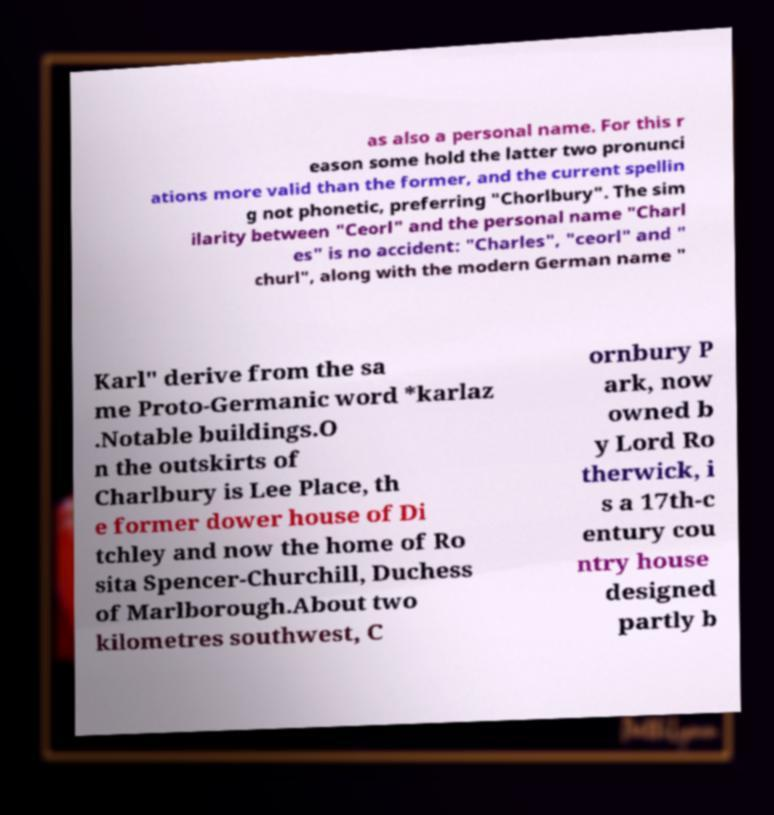Please identify and transcribe the text found in this image. as also a personal name. For this r eason some hold the latter two pronunci ations more valid than the former, and the current spellin g not phonetic, preferring "Chorlbury". The sim ilarity between "Ceorl" and the personal name "Charl es" is no accident: "Charles", "ceorl" and " churl", along with the modern German name " Karl" derive from the sa me Proto-Germanic word *karlaz .Notable buildings.O n the outskirts of Charlbury is Lee Place, th e former dower house of Di tchley and now the home of Ro sita Spencer-Churchill, Duchess of Marlborough.About two kilometres southwest, C ornbury P ark, now owned b y Lord Ro therwick, i s a 17th-c entury cou ntry house designed partly b 